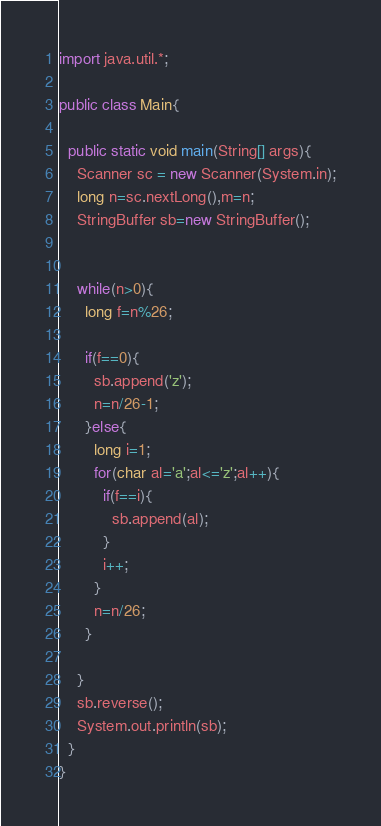Convert code to text. <code><loc_0><loc_0><loc_500><loc_500><_Java_>import java.util.*;

public class Main{
	
  public static void main(String[] args){
    Scanner sc = new Scanner(System.in);
  	long n=sc.nextLong(),m=n;
    StringBuffer sb=new StringBuffer();
    
    
    while(n>0){
      long f=n%26;
      
      if(f==0){
        sb.append('z');
        n=n/26-1;
      }else{
        long i=1;
        for(char al='a';al<='z';al++){
          if(f==i){
            sb.append(al);
          }
          i++;
        }
        n=n/26;
      }
      
    }
    sb.reverse();
    System.out.println(sb);
  }
}
</code> 